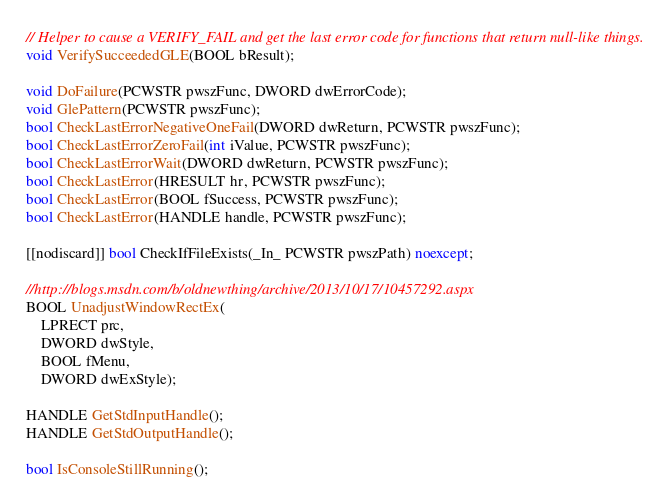<code> <loc_0><loc_0><loc_500><loc_500><_C++_>// Helper to cause a VERIFY_FAIL and get the last error code for functions that return null-like things.
void VerifySucceededGLE(BOOL bResult);

void DoFailure(PCWSTR pwszFunc, DWORD dwErrorCode);
void GlePattern(PCWSTR pwszFunc);
bool CheckLastErrorNegativeOneFail(DWORD dwReturn, PCWSTR pwszFunc);
bool CheckLastErrorZeroFail(int iValue, PCWSTR pwszFunc);
bool CheckLastErrorWait(DWORD dwReturn, PCWSTR pwszFunc);
bool CheckLastError(HRESULT hr, PCWSTR pwszFunc);
bool CheckLastError(BOOL fSuccess, PCWSTR pwszFunc);
bool CheckLastError(HANDLE handle, PCWSTR pwszFunc);

[[nodiscard]] bool CheckIfFileExists(_In_ PCWSTR pwszPath) noexcept;

//http://blogs.msdn.com/b/oldnewthing/archive/2013/10/17/10457292.aspx
BOOL UnadjustWindowRectEx(
    LPRECT prc,
    DWORD dwStyle,
    BOOL fMenu,
    DWORD dwExStyle);

HANDLE GetStdInputHandle();
HANDLE GetStdOutputHandle();

bool IsConsoleStillRunning();
</code> 